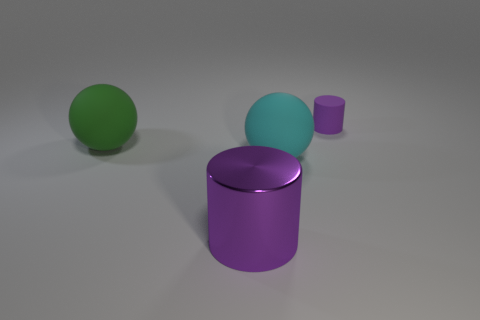Add 1 matte objects. How many objects exist? 5 Subtract all big brown rubber blocks. Subtract all small purple objects. How many objects are left? 3 Add 1 green objects. How many green objects are left? 2 Add 1 green spheres. How many green spheres exist? 2 Subtract 0 blue blocks. How many objects are left? 4 